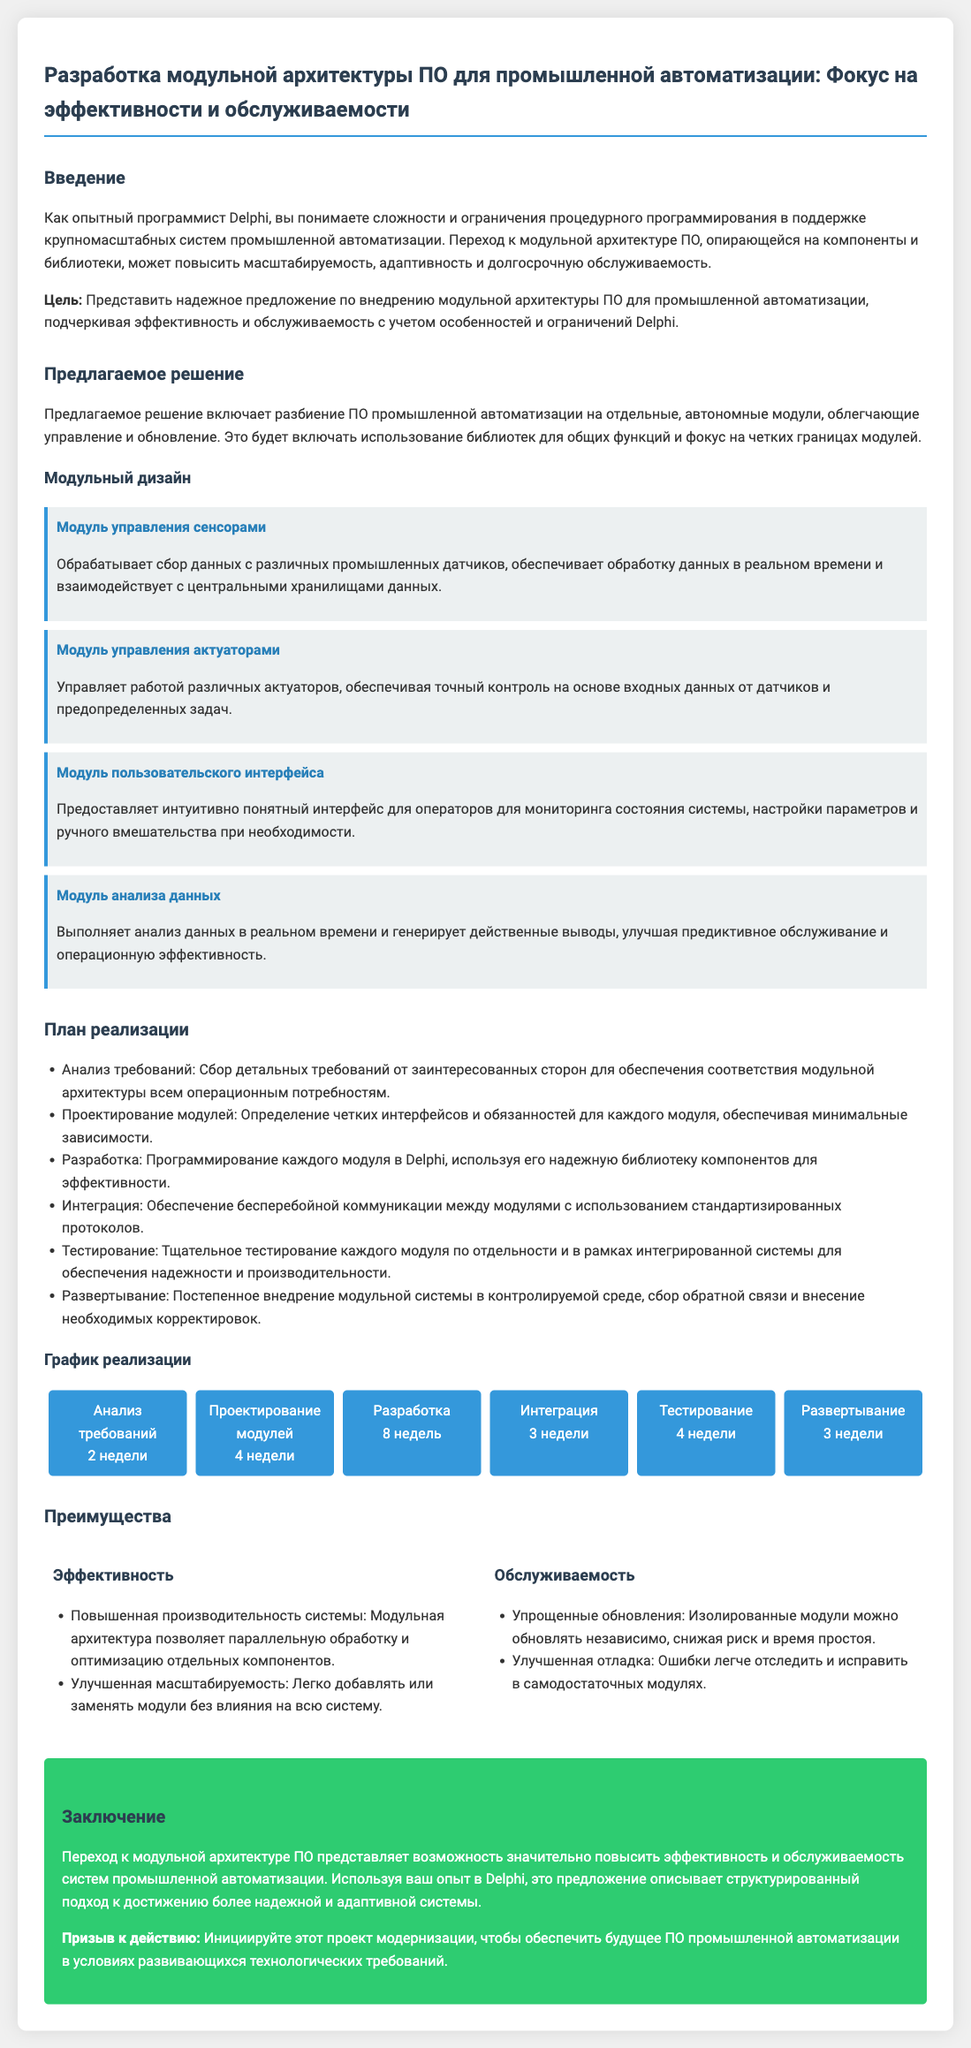Какова цель предложения? Цель предложения заключается в представлении надежного внедрения модульной архитектуры ПО для промышленной автоматизации, подчеркивая эффективность и обслуживаемость.
Answer: Представить надежное предложение Сколько модулей описано в предложении? В предложении описано 4 модуля, связанных с промышленной автоматизацией.
Answer: 4 Сколько недель запланировано на разработку? В документе указано, что на разработку запланировано 8 недель.
Answer: 8 недель Каковы основные преимущества модульной архитектуры? Модульная архитектура предлагает эффективность и обслуживаемость системы.
Answer: Эффективность и обслуживаемость Какой модуль отвечает за анализ данных? Модуль анализа данных выполняет анализ данных в реальном времени.
Answer: Модуль анализа данных Какой основной подход к проектированию модулей указан в предложении? Проектирование требует определения четких интерфейсов и обязанностей для каждого модуля с минимальными зависимостями.
Answer: Минимальные зависимости Какова продолжительность этапа интеграции согласно графику? Этап интеграции длится 3 недели по графику реализации.
Answer: 3 недели Какова основная цель этого документа? Основная цель заключается в повышении эффективности и обслуживаемости системы промышленной автоматизации.
Answer: Повышение эффективности и обслуживаемости 